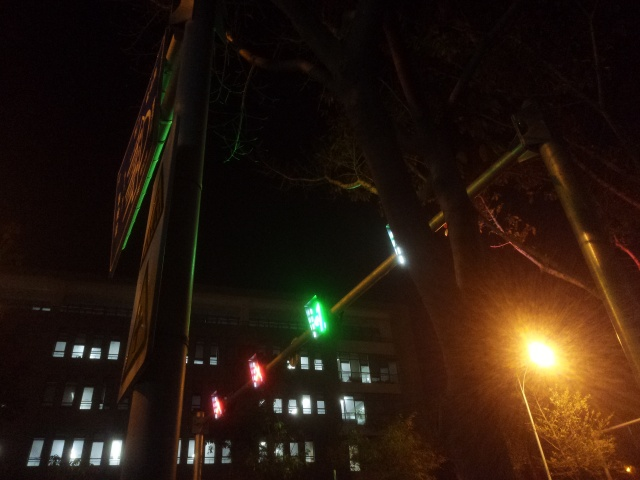Can you describe the mood or atmosphere of this picture? The image portrays a serene and quiet urban night setting. The glowing traffic lights and street lamp give off a calm and still vibe, possibly reflecting a moment of low activity in the city. 